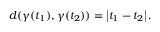Convert formula to latex. <formula><loc_0><loc_0><loc_500><loc_500>d ( \gamma ( t _ { 1 } ) , \gamma ( t _ { 2 } ) ) = \left | t _ { 1 } - t _ { 2 } \right | .</formula> 